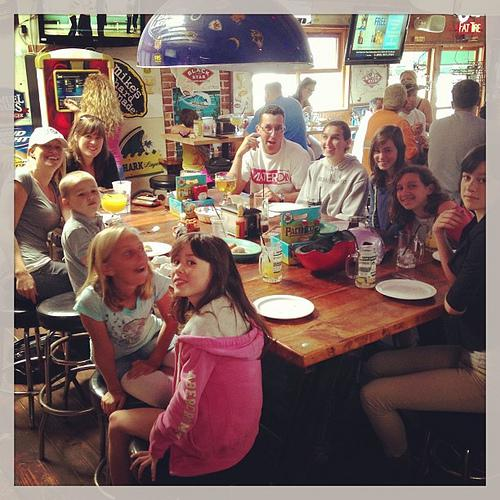Question: where does this image take place?
Choices:
A. At a circus.
B. At a concert.
C. At a awards show.
D. At a restaurant.
Answer with the letter. Answer: D Question: what color is the table?
Choices:
A. White.
B. Yellow.
C. Green.
D. Brown.
Answer with the letter. Answer: D Question: how many children are sitting on the left side of the table?
Choices:
A. 4.
B. 2.
C. 1.
D. 3.
Answer with the letter. Answer: D Question: how many cats are in the image?
Choices:
A. 1.
B. 2.
C. 3.
D. 0.
Answer with the letter. Answer: D 